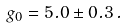Convert formula to latex. <formula><loc_0><loc_0><loc_500><loc_500>g _ { 0 } = 5 . 0 \pm 0 . 3 \, .</formula> 